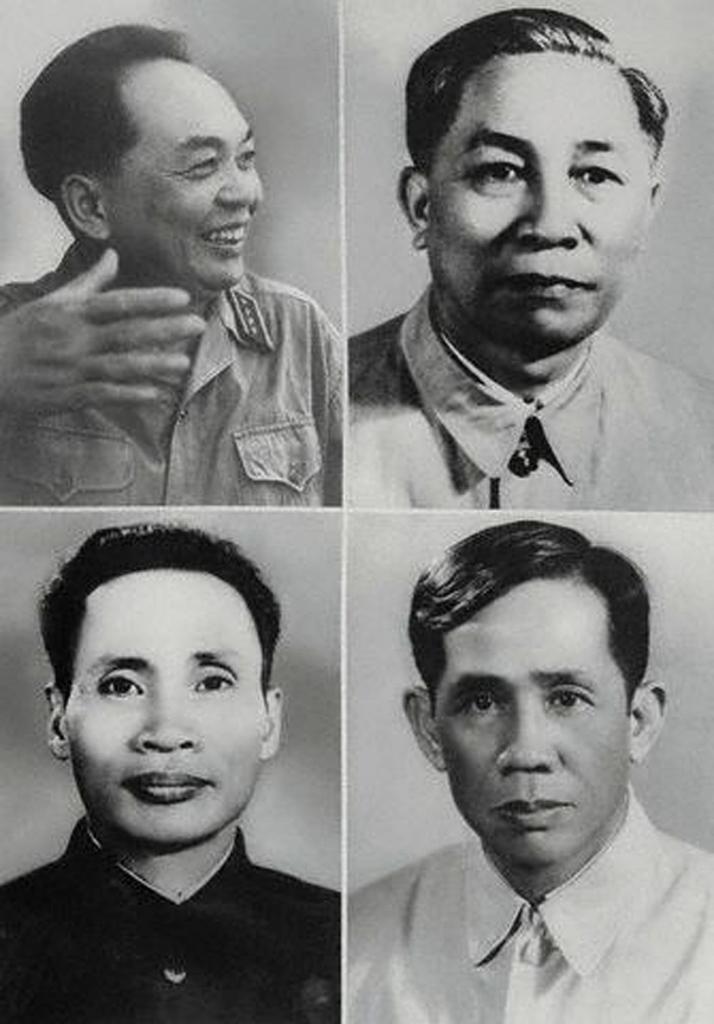In one or two sentences, can you explain what this image depicts? In this image there is a black and white picture of four different people. 